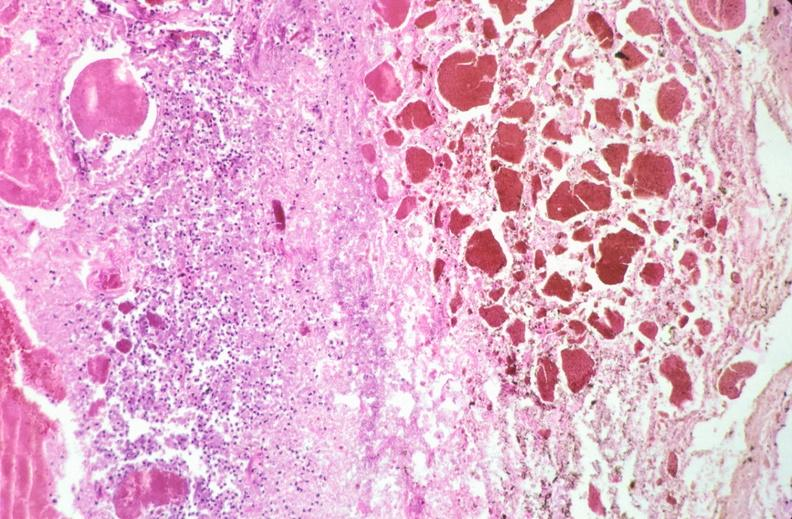what is stomach , necrotizing esophagitis and gastritis , sulfuric acid ingested?
Answer the question using a single word or phrase. As suicide attempt 